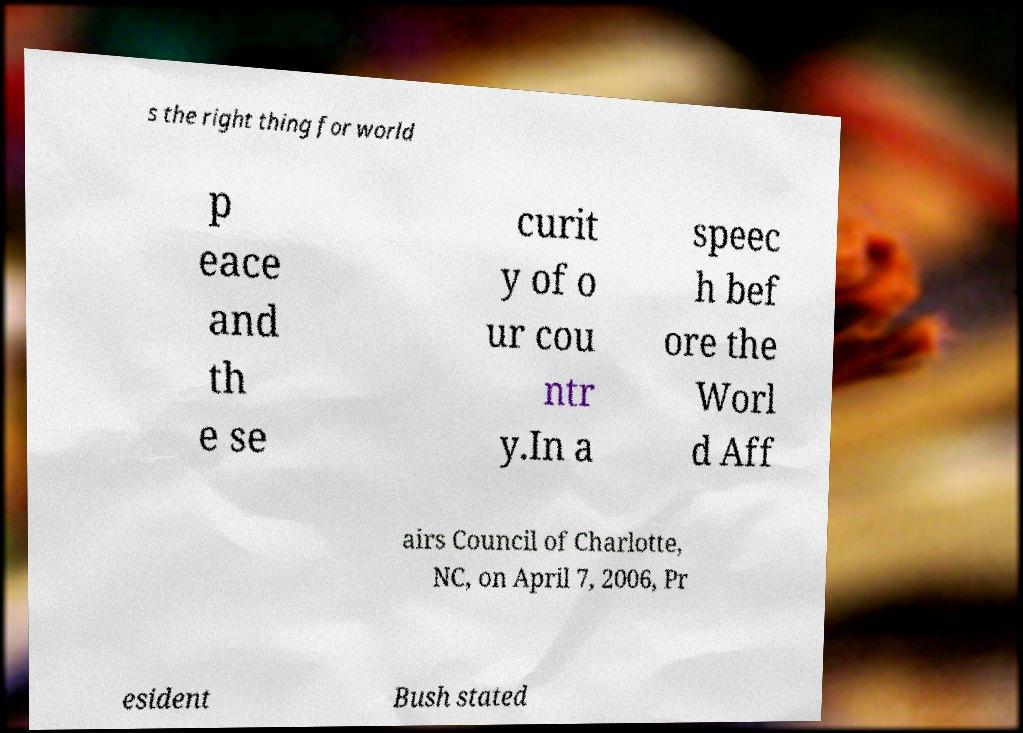What messages or text are displayed in this image? I need them in a readable, typed format. s the right thing for world p eace and th e se curit y of o ur cou ntr y.In a speec h bef ore the Worl d Aff airs Council of Charlotte, NC, on April 7, 2006, Pr esident Bush stated 